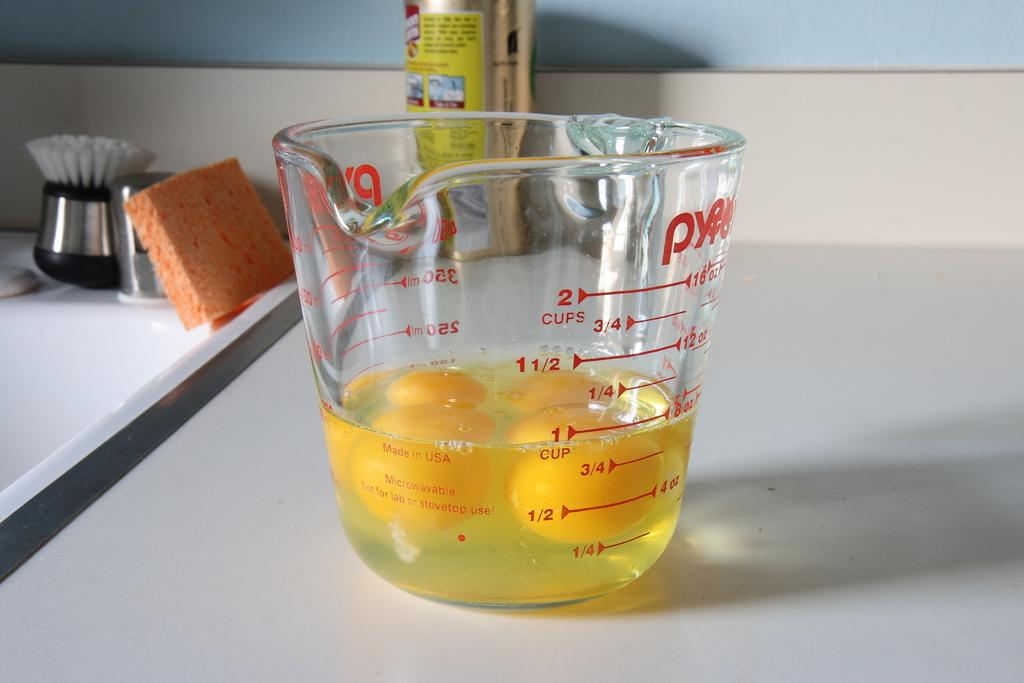<image>
Relay a brief, clear account of the picture shown. a measuring cup is filled with 1 cup of eggs 